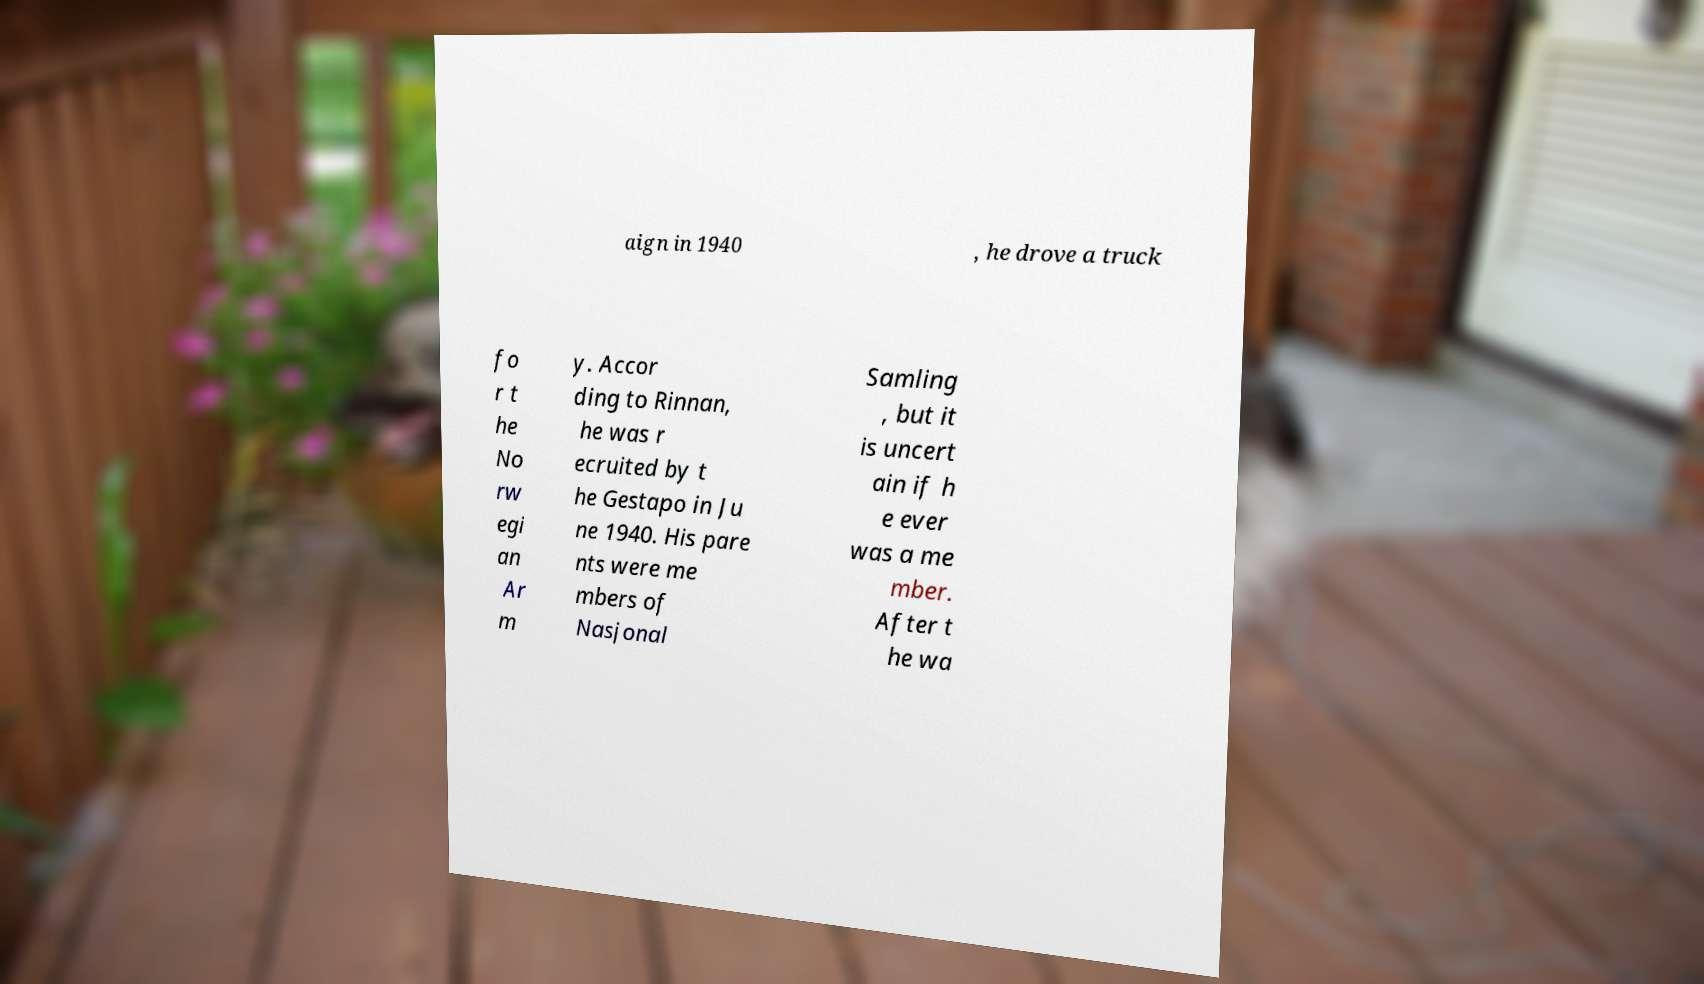Could you assist in decoding the text presented in this image and type it out clearly? aign in 1940 , he drove a truck fo r t he No rw egi an Ar m y. Accor ding to Rinnan, he was r ecruited by t he Gestapo in Ju ne 1940. His pare nts were me mbers of Nasjonal Samling , but it is uncert ain if h e ever was a me mber. After t he wa 